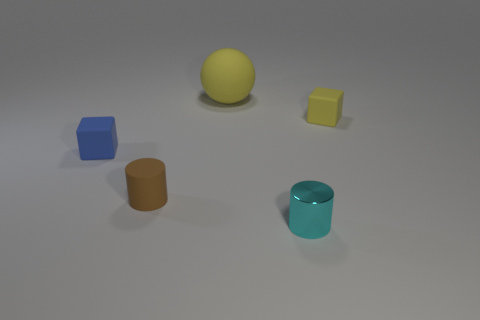Add 2 brown cylinders. How many objects exist? 7 Subtract all blocks. How many objects are left? 3 Subtract 0 purple spheres. How many objects are left? 5 Subtract all big gray shiny balls. Subtract all blocks. How many objects are left? 3 Add 5 yellow blocks. How many yellow blocks are left? 6 Add 4 cyan things. How many cyan things exist? 5 